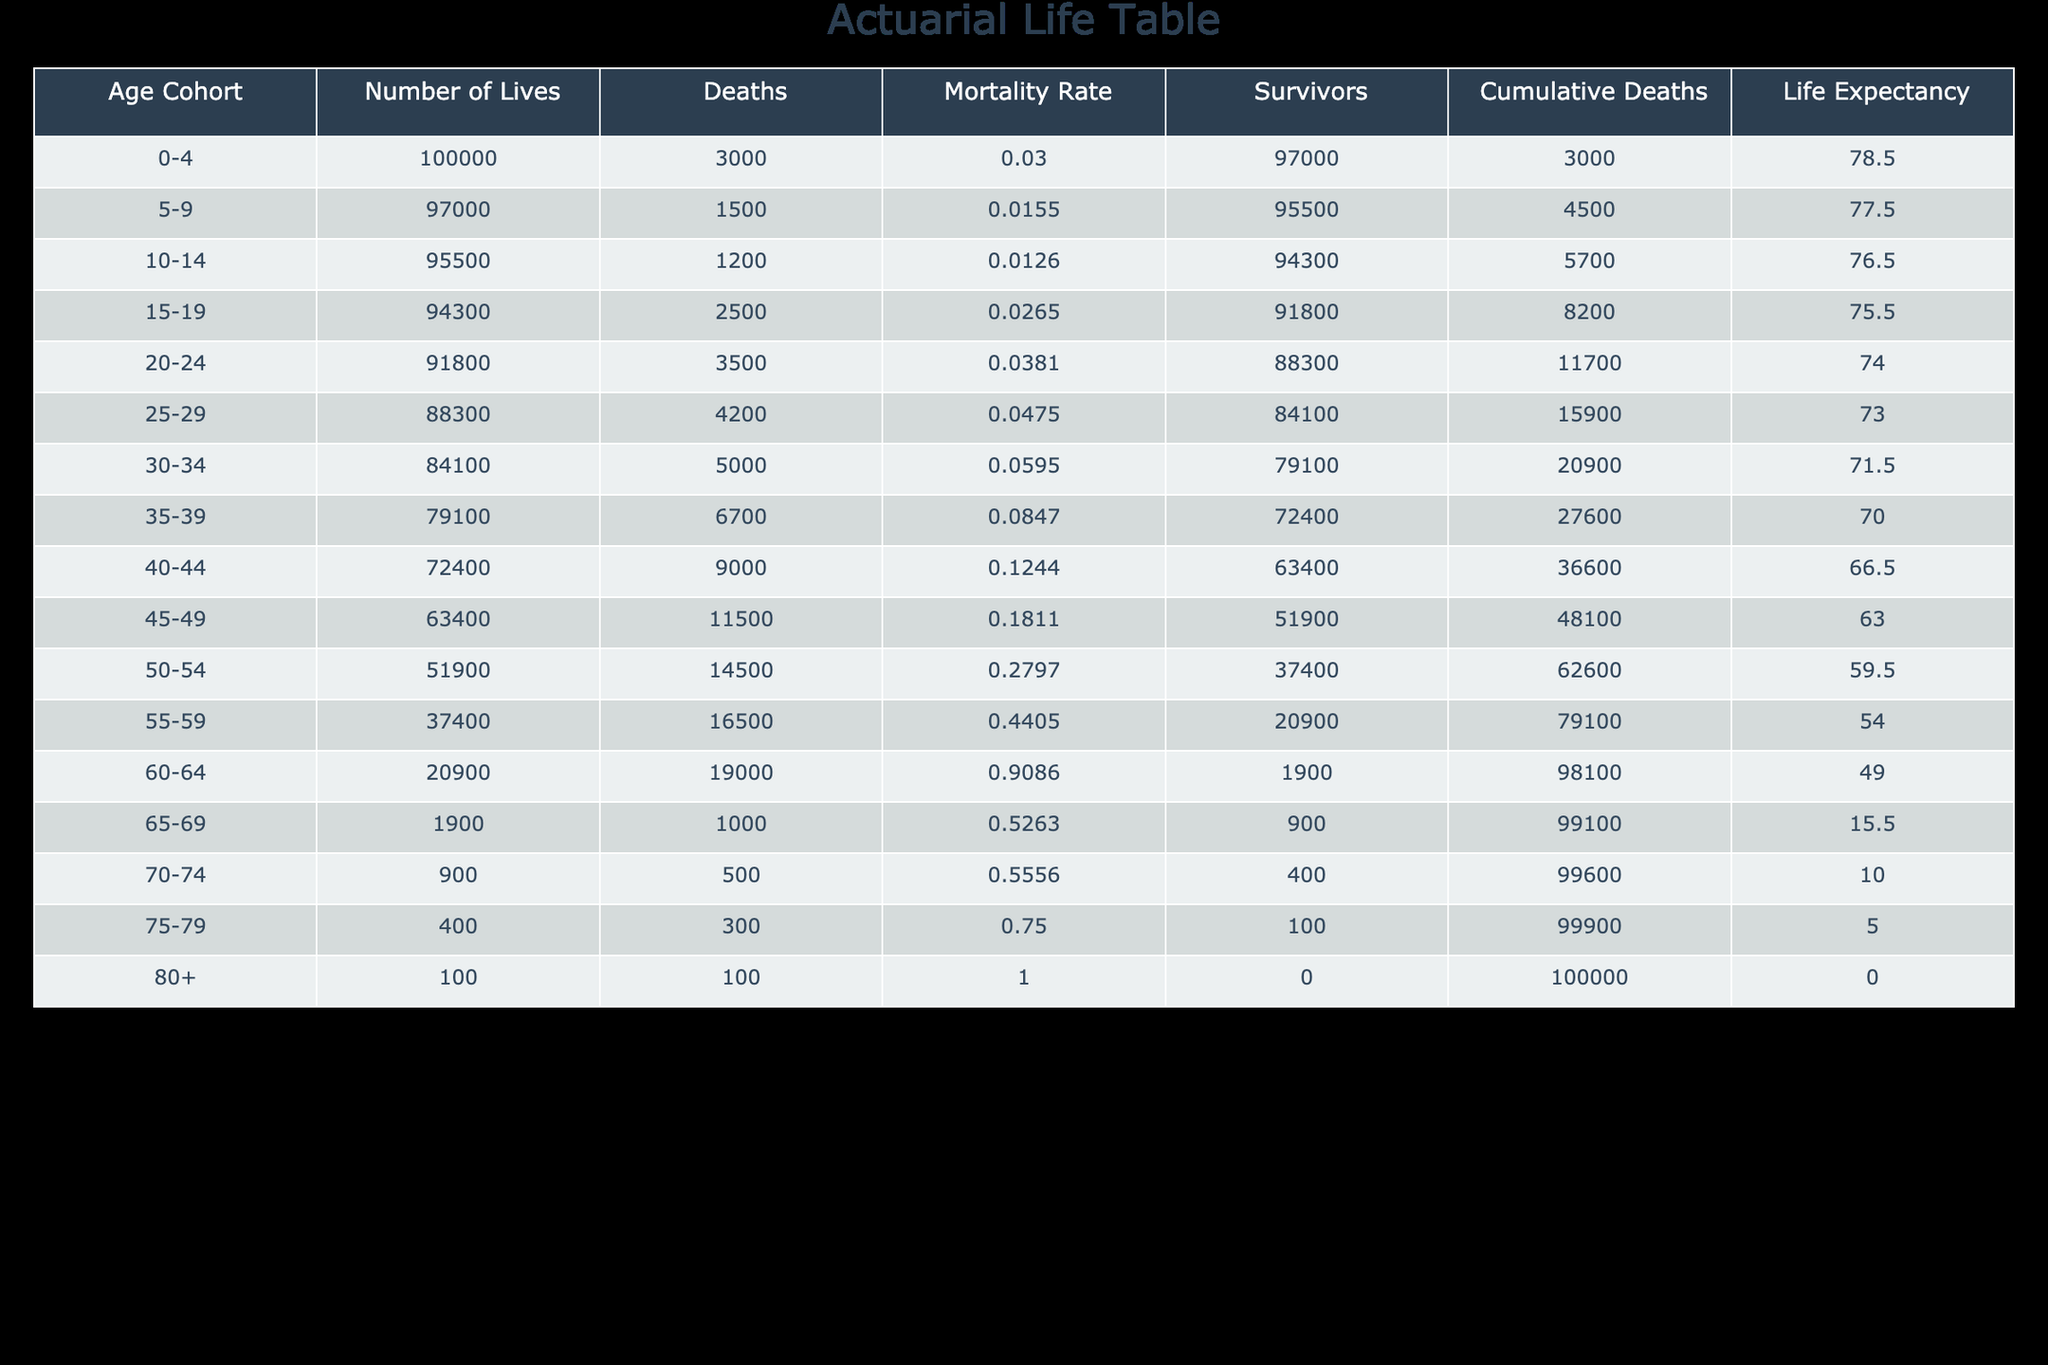What is the mortality rate for the age cohort 40-44? The mortality rate for the age cohort 40-44 is provided directly in the table under the "Mortality Rate" column for that age range. Referring to that row, the value is 0.1244.
Answer: 0.1244 How many survivors are there in the age cohort 55-59? The number of survivors for the age cohort 55-59 can be found in the table under the "Survivors" column. Looking at that row, the number of survivors is 20900.
Answer: 20900 What is the cumulative number of deaths for the age cohort 50-54? The cumulative number of deaths for the age cohort 50-54 is listed in the "Cumulative Deaths" column. In the row for that age cohort, it shows 62600.
Answer: 62600 Is the mortality rate for the age cohort 75-79 greater than 0.7? The mortality rate for the age cohort 75-79 is 0.75 as stated in the table. Since 0.75 is indeed greater than 0.7, the answer is yes.
Answer: Yes What is the average number of lives for the cohorts aged 50-54 and 55-59 combined? To find the average, first sum the number of lives in both cohorts: 51900 (for 50-54) + 37400 (for 55-59) = 89300. Then, divide by 2, as there are 2 cohorts: 89300 / 2 = 44650.
Answer: 44650 What is the total number of deaths for the age cohorts 0-4 and 5-9 combined? For age cohorts 0-4 and 5-9, the deaths are 3000 and 1500, respectively. Adding these gives 3000 + 1500 = 4500.
Answer: 4500 Is the life expectancy for the age cohort 60-64 less than 50 years? The life expectancy for the age cohort 60-64 is 49.0 according to the table. Since 49.0 is less than 50, the answer is yes.
Answer: Yes What age cohort has the highest mortality rate? Looking at the "Mortality Rate" column, the cohort with the highest value is 60-64, which has a mortality rate of 0.9086.
Answer: 60-64 What is the difference in life expectancy between the age cohorts 15-19 and 20-24? The life expectancy for 15-19 is 75.5, and for 20-24, it is 74.0. The difference is 75.5 - 74.0 = 1.5.
Answer: 1.5 